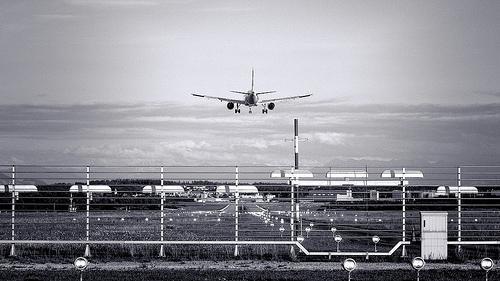How many planes are there?
Give a very brief answer. 1. How many airplanes in the sky?
Give a very brief answer. 1. How many lights along the airstrip?
Give a very brief answer. 4. 